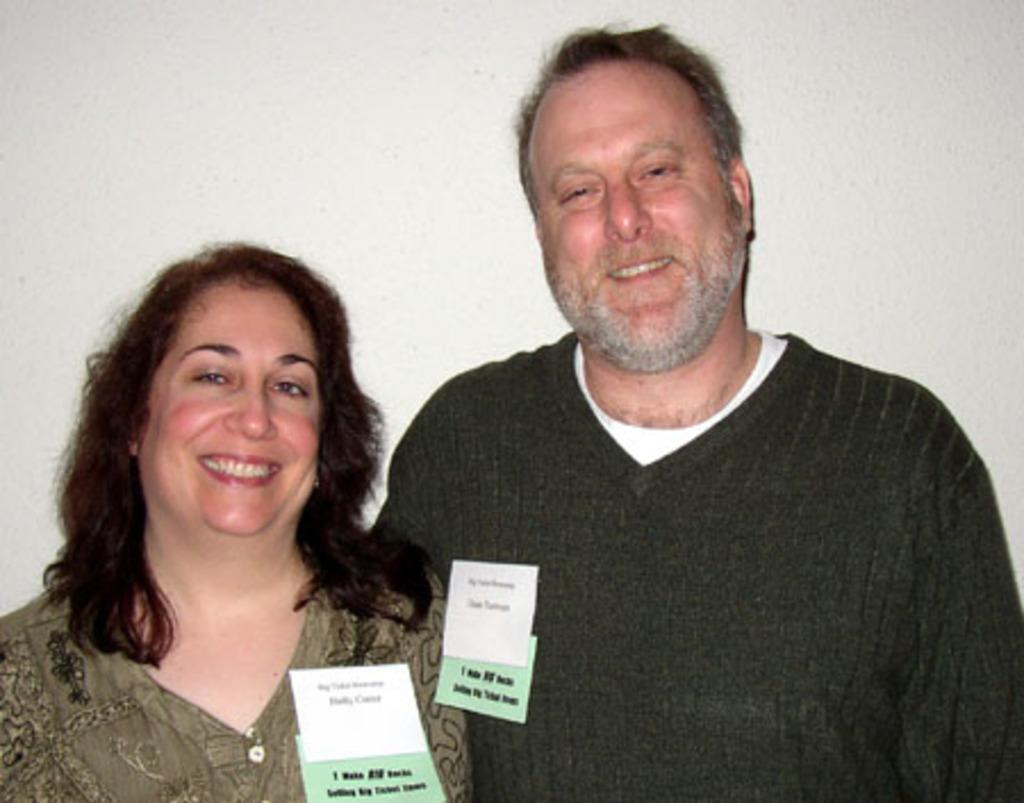Can you describe this image briefly? In this image I can see two people. In the background, I can see the wall. 